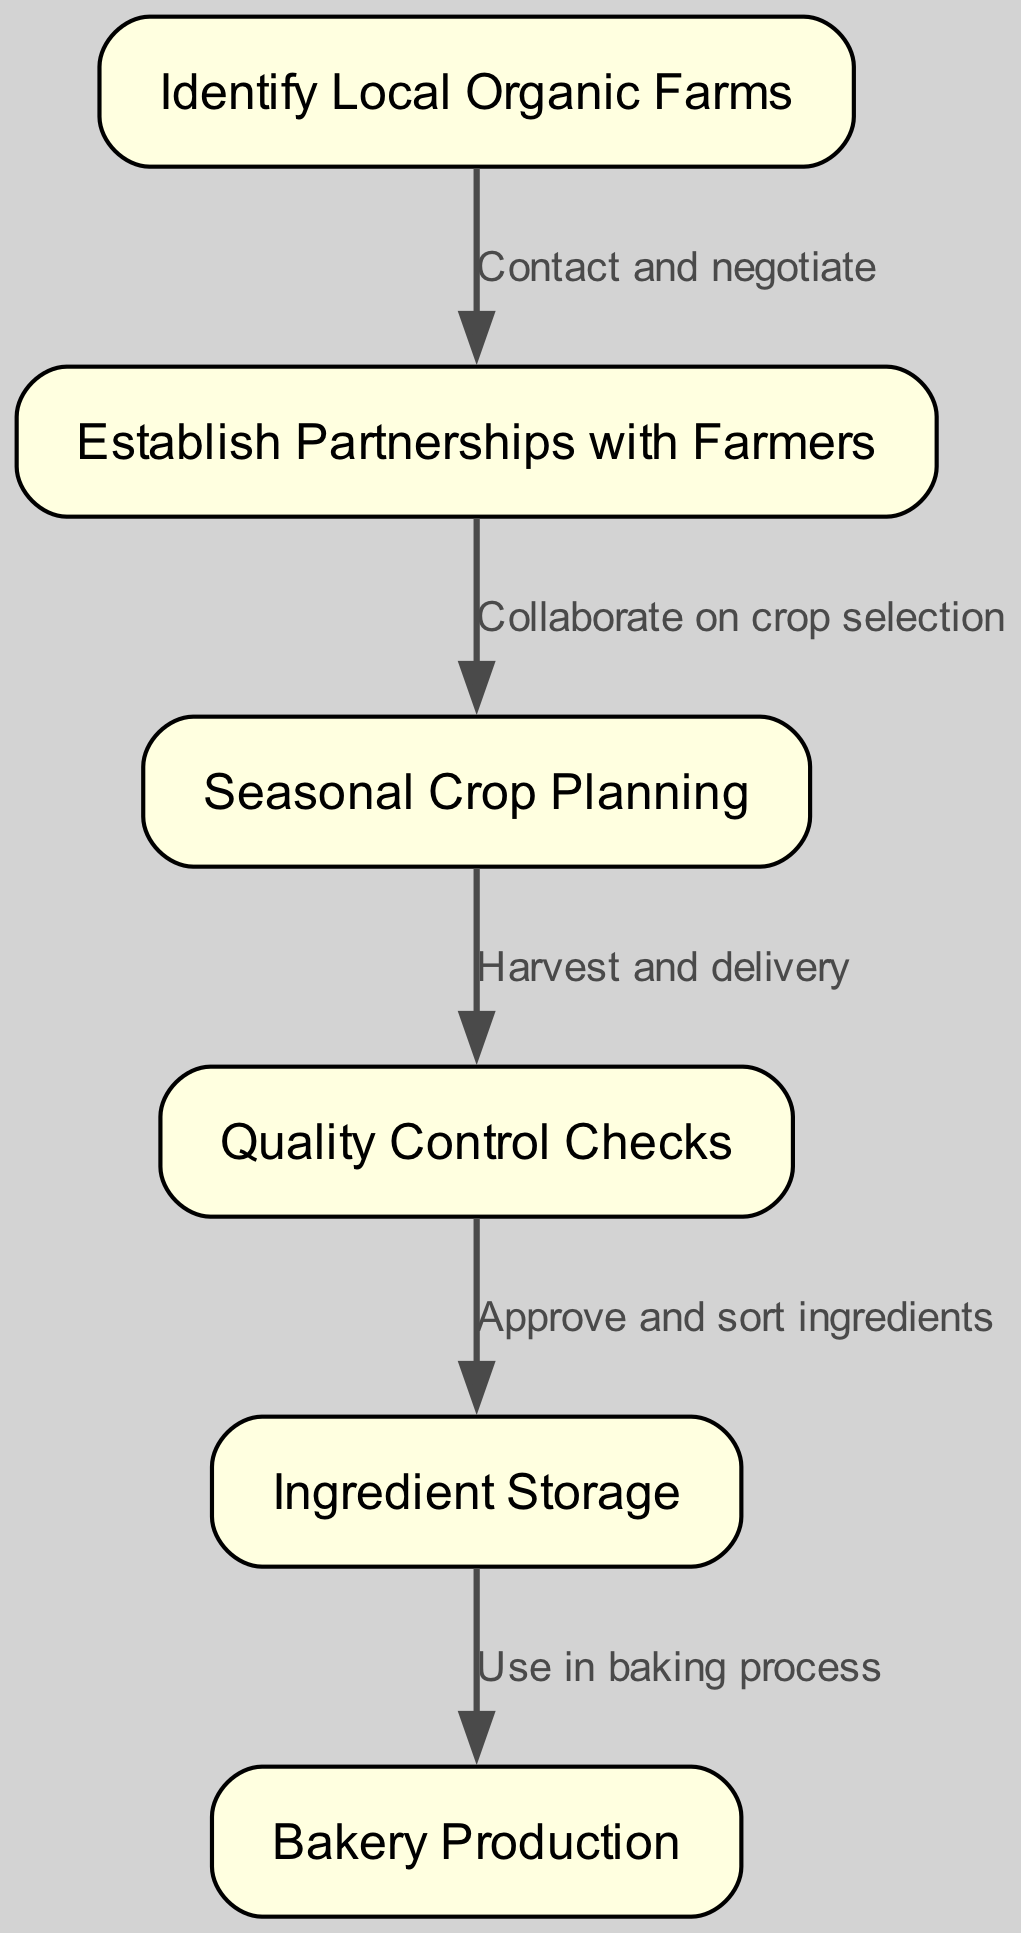What is the first step in the supply chain management? The first step in the diagram is "Identify Local Organic Farms," which is indicated as the starting node in the flow.
Answer: Identify Local Organic Farms How many nodes are in the diagram? The diagram consists of 6 nodes, which represent various steps in the supply chain process.
Answer: 6 What relationship exists between the nodes "Establish Partnerships with Farmers" and "Seasonal Crop Planning"? The relationship between these two nodes is "Collaborate on crop selection," which shows how partnerships lead to planning.
Answer: Collaborate on crop selection What is the last step in the supply chain management process? The last step depicted in the diagram is "Bakery Production," indicating that all previous actions lead to the production process.
Answer: Bakery Production How many edges connect the nodes in the diagram? There are 5 edges connecting the nodes, which represent the relationships between the various steps in the supply chain.
Answer: 5 What happens after "Quality Control Checks"? After "Quality Control Checks," the next step is "Ingredient Storage," as indicated by the flow direction shown by the edges.
Answer: Ingredient Storage Which node comes immediately after "Ingredient Storage"? The node that follows "Ingredient Storage" is "Bakery Production," as it is the next step in the process.
Answer: Bakery Production What is the action indicated from "Harvest and delivery" to "Quality Control Checks"? The action indicated is "Harvest and delivery," which shows the process of bringing in fresh ingredients for quality assessment.
Answer: Harvest and delivery What do you achieve by "Approve and sort ingredients"? "Approve and sort ingredients" leads to the next step of "Ingredient Storage," ensuring that only quality ingredients are kept for further use.
Answer: Ingredient Storage 